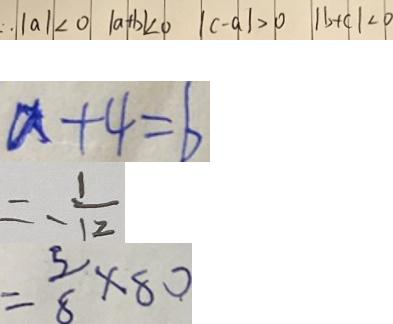<formula> <loc_0><loc_0><loc_500><loc_500>\therefore \vert a \vert < 0 \vert a + b \vert < 0 \vert c - a \vert > 0 \vert b + c \vert < 0 
 a + 4 = b 
 = - \frac { 1 } { 1 2 } 
 = \frac { 5 } { 8 } \times 8 0</formula> 